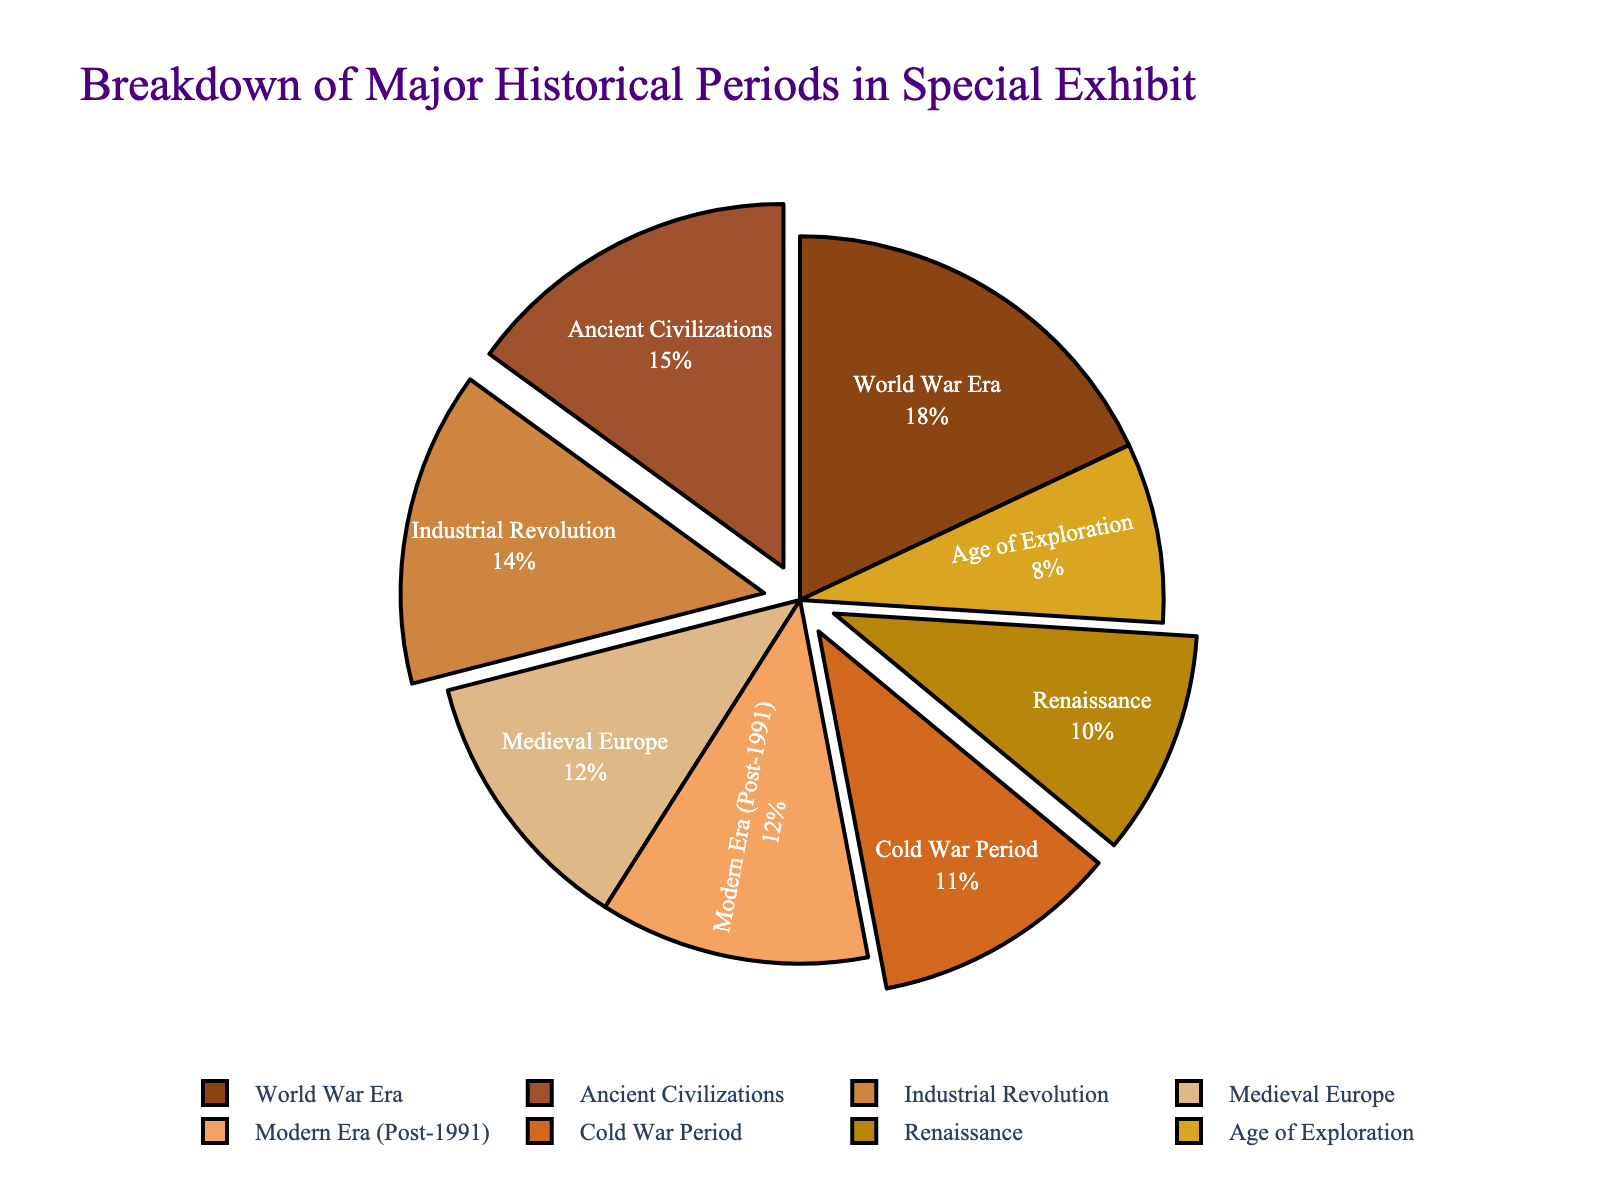Which historical period has the smallest representation in the exhibit? By looking at the figure, we can identify the section with the smallest size in the pie chart, which represents the lowest percentage.
Answer: Age of Exploration Which two periods together make up the largest portion of the exhibit? Adding up the two largest sections in the pie chart—World War Era (18%) and Ancient Civilizations (15%)—gives the largest combined portion.
Answer: World War Era and Ancient Civilizations What portion of the exhibit is dedicated to the Industrial Revolution compared to the Cold War Period? By comparing the slices of the pie chart, we see that the Industrial Revolution is 14% and the Cold War Period is 11%.
Answer: Industrial Revolution is larger How many historical periods account for more than 10% each in the exhibit? By examining the pie chart, we note the sections with percentages higher than 10%. They are Ancient Civilizations (15%), Medieval Europe (12%), Industrial Revolution (14%), World War Era (18%), and Cold War Period (11%).
Answer: Five periods What is the combined percentage of the Renaissance and Modern Era (Post-1991)? Adding the percentages for the Renaissance (10%) and Modern Era (Post-1991) (12%) gives a total of 22%.
Answer: 22% Is the proportion of content covering Medieval Europe equal to the Modern Era (Post-1991)? Comparing the slices for Medieval Europe (12%) and Modern Era (Post-1991) (12%) shows they are equal.
Answer: Yes Which slice of the pie chart is represented in a lighter brown shade? The lighter brown shades can be distinguished visually. By looking closely, we can identify which section corresponds to a lighter brown.
Answer: Age of Exploration If we combine the percentages of the Age of Exploration and the Renaissance, does it exceed that of the World War Era? Adding the Age of Exploration (8%) and the Renaissance (10%) results in 18%, which matches the World War Era (18%), so it does not exceed it.
Answer: No What percentage is allocated to periods outside of World War Era and Ancient Civilizations? Subtracting the combined percentage of World War Era (18%) and Ancient Civilizations (15%) from 100% gives 67%.
Answer: 67% 